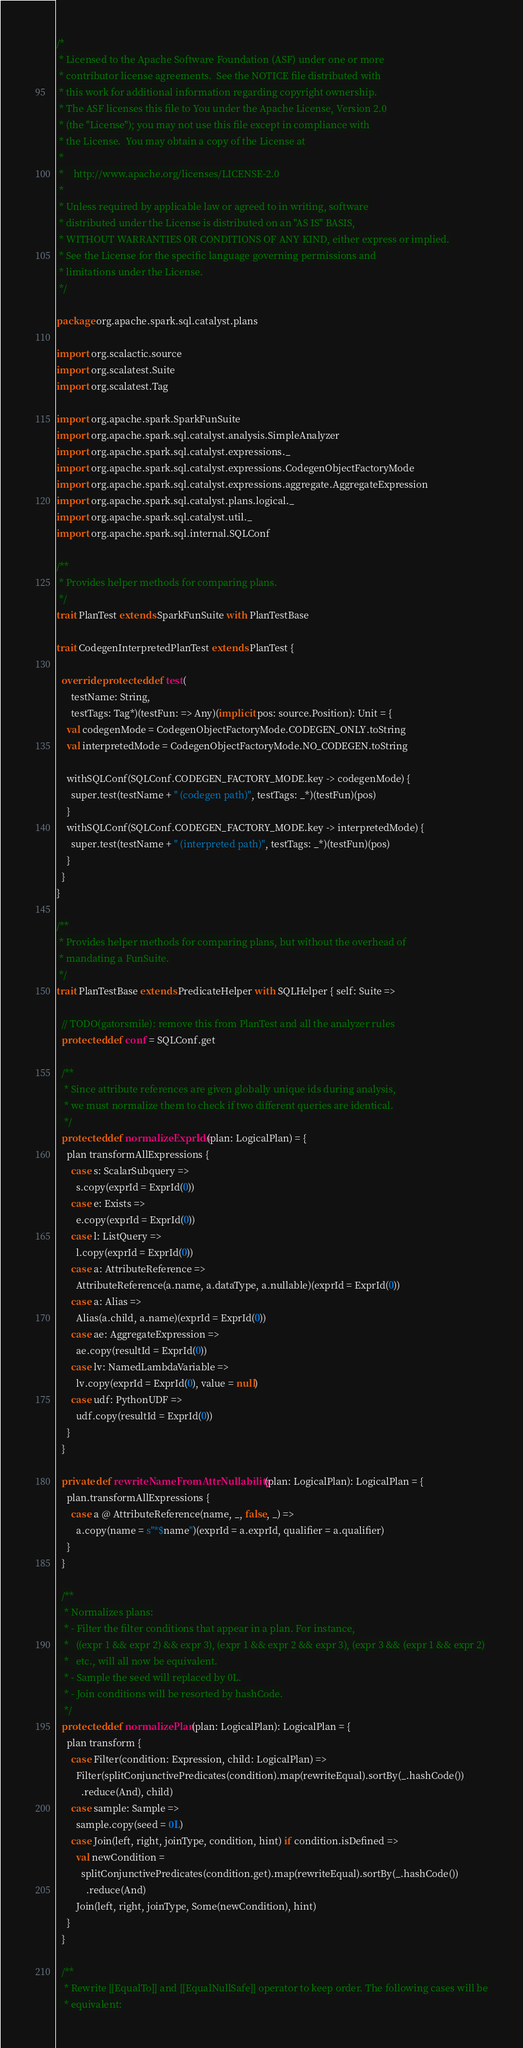Convert code to text. <code><loc_0><loc_0><loc_500><loc_500><_Scala_>/*
 * Licensed to the Apache Software Foundation (ASF) under one or more
 * contributor license agreements.  See the NOTICE file distributed with
 * this work for additional information regarding copyright ownership.
 * The ASF licenses this file to You under the Apache License, Version 2.0
 * (the "License"); you may not use this file except in compliance with
 * the License.  You may obtain a copy of the License at
 *
 *    http://www.apache.org/licenses/LICENSE-2.0
 *
 * Unless required by applicable law or agreed to in writing, software
 * distributed under the License is distributed on an "AS IS" BASIS,
 * WITHOUT WARRANTIES OR CONDITIONS OF ANY KIND, either express or implied.
 * See the License for the specific language governing permissions and
 * limitations under the License.
 */

package org.apache.spark.sql.catalyst.plans

import org.scalactic.source
import org.scalatest.Suite
import org.scalatest.Tag

import org.apache.spark.SparkFunSuite
import org.apache.spark.sql.catalyst.analysis.SimpleAnalyzer
import org.apache.spark.sql.catalyst.expressions._
import org.apache.spark.sql.catalyst.expressions.CodegenObjectFactoryMode
import org.apache.spark.sql.catalyst.expressions.aggregate.AggregateExpression
import org.apache.spark.sql.catalyst.plans.logical._
import org.apache.spark.sql.catalyst.util._
import org.apache.spark.sql.internal.SQLConf

/**
 * Provides helper methods for comparing plans.
 */
trait PlanTest extends SparkFunSuite with PlanTestBase

trait CodegenInterpretedPlanTest extends PlanTest {

  override protected def test(
      testName: String,
      testTags: Tag*)(testFun: => Any)(implicit pos: source.Position): Unit = {
    val codegenMode = CodegenObjectFactoryMode.CODEGEN_ONLY.toString
    val interpretedMode = CodegenObjectFactoryMode.NO_CODEGEN.toString

    withSQLConf(SQLConf.CODEGEN_FACTORY_MODE.key -> codegenMode) {
      super.test(testName + " (codegen path)", testTags: _*)(testFun)(pos)
    }
    withSQLConf(SQLConf.CODEGEN_FACTORY_MODE.key -> interpretedMode) {
      super.test(testName + " (interpreted path)", testTags: _*)(testFun)(pos)
    }
  }
}

/**
 * Provides helper methods for comparing plans, but without the overhead of
 * mandating a FunSuite.
 */
trait PlanTestBase extends PredicateHelper with SQLHelper { self: Suite =>

  // TODO(gatorsmile): remove this from PlanTest and all the analyzer rules
  protected def conf = SQLConf.get

  /**
   * Since attribute references are given globally unique ids during analysis,
   * we must normalize them to check if two different queries are identical.
   */
  protected def normalizeExprIds(plan: LogicalPlan) = {
    plan transformAllExpressions {
      case s: ScalarSubquery =>
        s.copy(exprId = ExprId(0))
      case e: Exists =>
        e.copy(exprId = ExprId(0))
      case l: ListQuery =>
        l.copy(exprId = ExprId(0))
      case a: AttributeReference =>
        AttributeReference(a.name, a.dataType, a.nullable)(exprId = ExprId(0))
      case a: Alias =>
        Alias(a.child, a.name)(exprId = ExprId(0))
      case ae: AggregateExpression =>
        ae.copy(resultId = ExprId(0))
      case lv: NamedLambdaVariable =>
        lv.copy(exprId = ExprId(0), value = null)
      case udf: PythonUDF =>
        udf.copy(resultId = ExprId(0))
    }
  }

  private def rewriteNameFromAttrNullability(plan: LogicalPlan): LogicalPlan = {
    plan.transformAllExpressions {
      case a @ AttributeReference(name, _, false, _) =>
        a.copy(name = s"*$name")(exprId = a.exprId, qualifier = a.qualifier)
    }
  }

  /**
   * Normalizes plans:
   * - Filter the filter conditions that appear in a plan. For instance,
   *   ((expr 1 && expr 2) && expr 3), (expr 1 && expr 2 && expr 3), (expr 3 && (expr 1 && expr 2)
   *   etc., will all now be equivalent.
   * - Sample the seed will replaced by 0L.
   * - Join conditions will be resorted by hashCode.
   */
  protected def normalizePlan(plan: LogicalPlan): LogicalPlan = {
    plan transform {
      case Filter(condition: Expression, child: LogicalPlan) =>
        Filter(splitConjunctivePredicates(condition).map(rewriteEqual).sortBy(_.hashCode())
          .reduce(And), child)
      case sample: Sample =>
        sample.copy(seed = 0L)
      case Join(left, right, joinType, condition, hint) if condition.isDefined =>
        val newCondition =
          splitConjunctivePredicates(condition.get).map(rewriteEqual).sortBy(_.hashCode())
            .reduce(And)
        Join(left, right, joinType, Some(newCondition), hint)
    }
  }

  /**
   * Rewrite [[EqualTo]] and [[EqualNullSafe]] operator to keep order. The following cases will be
   * equivalent:</code> 